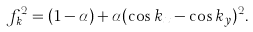<formula> <loc_0><loc_0><loc_500><loc_500>f _ { k } ^ { 2 } = ( 1 - \alpha ) + \alpha ( \cos k _ { x } - \cos k _ { y } ) ^ { 2 } .</formula> 